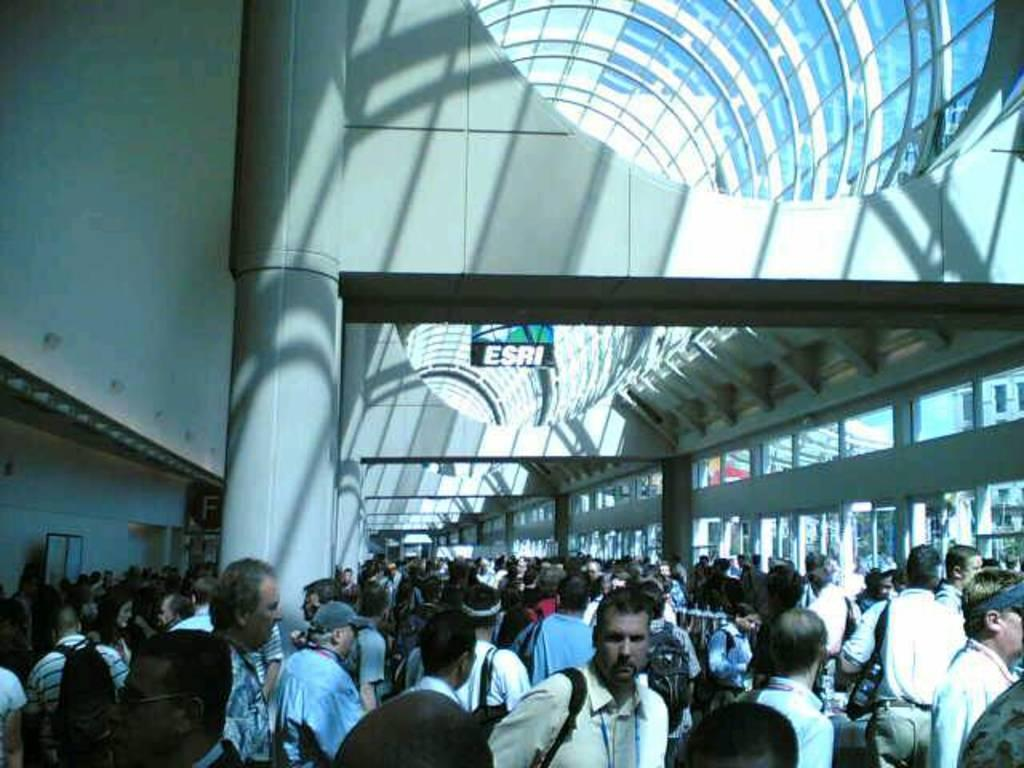What is the main subject of the image? The main subject of the image is a crowd. Where is the crowd located? The crowd is inside a building. What is the building made of? The building is covered with glass. What type of fog can be seen in the image? There is no fog present in the image; it features a crowd inside a glass-covered building. 